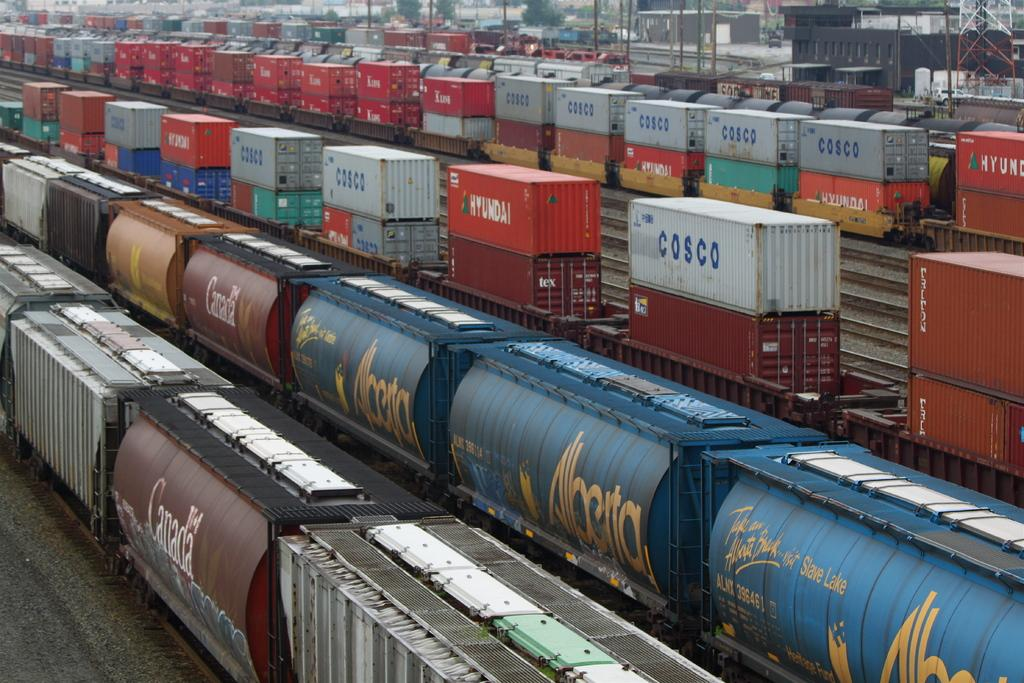<image>
Share a concise interpretation of the image provided. A fright train yard with containers from various shippers like Costco canada national line 